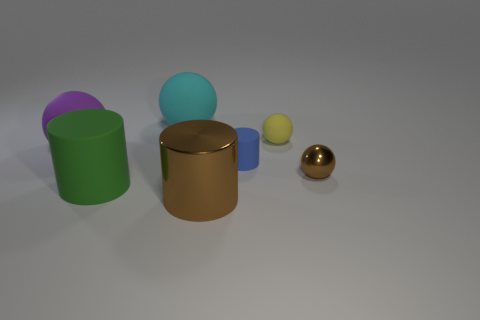There is a object that is the same color as the tiny metallic sphere; what material is it?
Keep it short and to the point. Metal. Are there any large cyan rubber things that have the same shape as the green object?
Your answer should be very brief. No. How big is the brown shiny object that is in front of the shiny ball?
Your answer should be very brief. Large. What material is the other ball that is the same size as the yellow sphere?
Provide a short and direct response. Metal. Are there more brown shiny balls than large matte things?
Your answer should be compact. No. There is a ball that is in front of the matte ball to the left of the big cyan thing; what is its size?
Provide a succinct answer. Small. There is another matte thing that is the same size as the yellow rubber thing; what shape is it?
Offer a terse response. Cylinder. The cyan object that is on the left side of the small object that is in front of the matte cylinder that is behind the brown ball is what shape?
Provide a succinct answer. Sphere. There is a rubber object that is in front of the blue rubber cylinder; is its color the same as the tiny ball that is behind the purple thing?
Your answer should be very brief. No. What number of large gray matte blocks are there?
Your response must be concise. 0. 